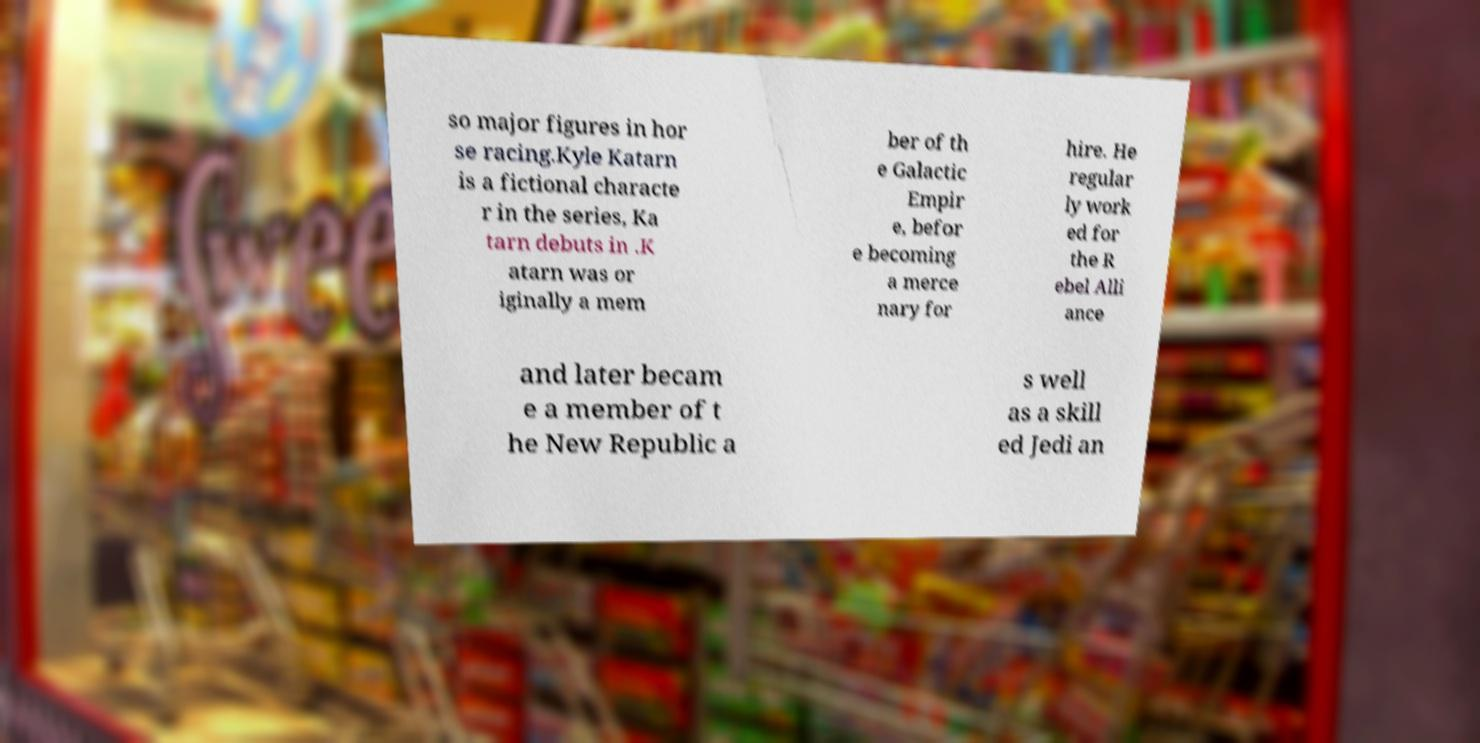I need the written content from this picture converted into text. Can you do that? so major figures in hor se racing.Kyle Katarn is a fictional characte r in the series, Ka tarn debuts in .K atarn was or iginally a mem ber of th e Galactic Empir e, befor e becoming a merce nary for hire. He regular ly work ed for the R ebel Alli ance and later becam e a member of t he New Republic a s well as a skill ed Jedi an 